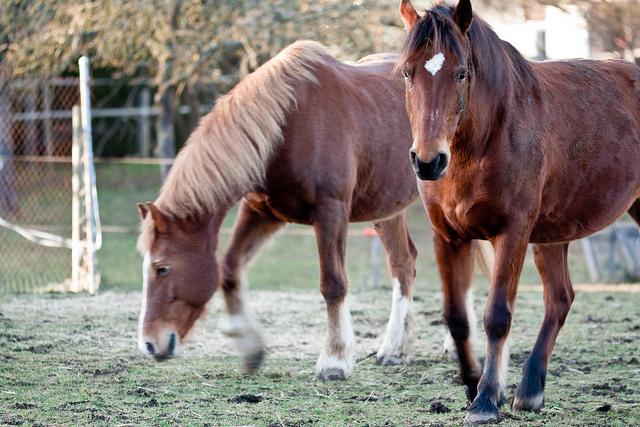Does the grass need to be cut?
Write a very short answer. No. Is the horse alone?
Keep it brief. No. What is the horse looking at?
Short answer required. Camera. The horse in the front have what color mark on his head?
Be succinct. White. Is the white spot on the horse's head made of paint?
Give a very brief answer. No. 